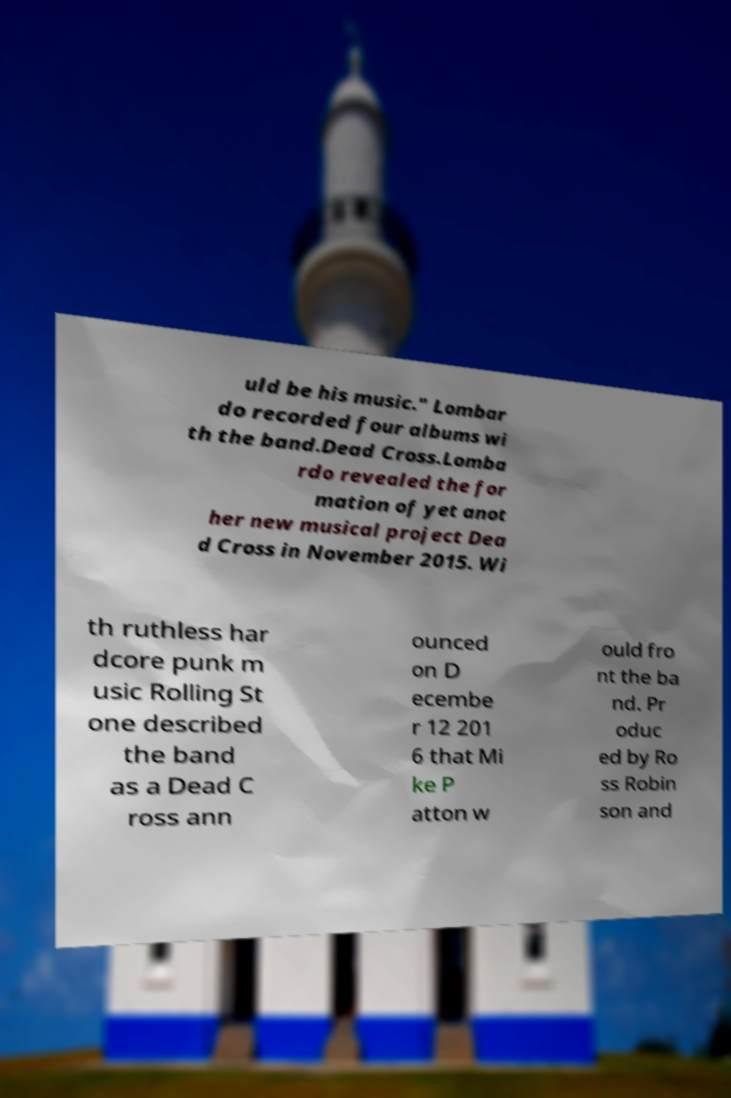Please read and relay the text visible in this image. What does it say? uld be his music." Lombar do recorded four albums wi th the band.Dead Cross.Lomba rdo revealed the for mation of yet anot her new musical project Dea d Cross in November 2015. Wi th ruthless har dcore punk m usic Rolling St one described the band as a Dead C ross ann ounced on D ecembe r 12 201 6 that Mi ke P atton w ould fro nt the ba nd. Pr oduc ed by Ro ss Robin son and 